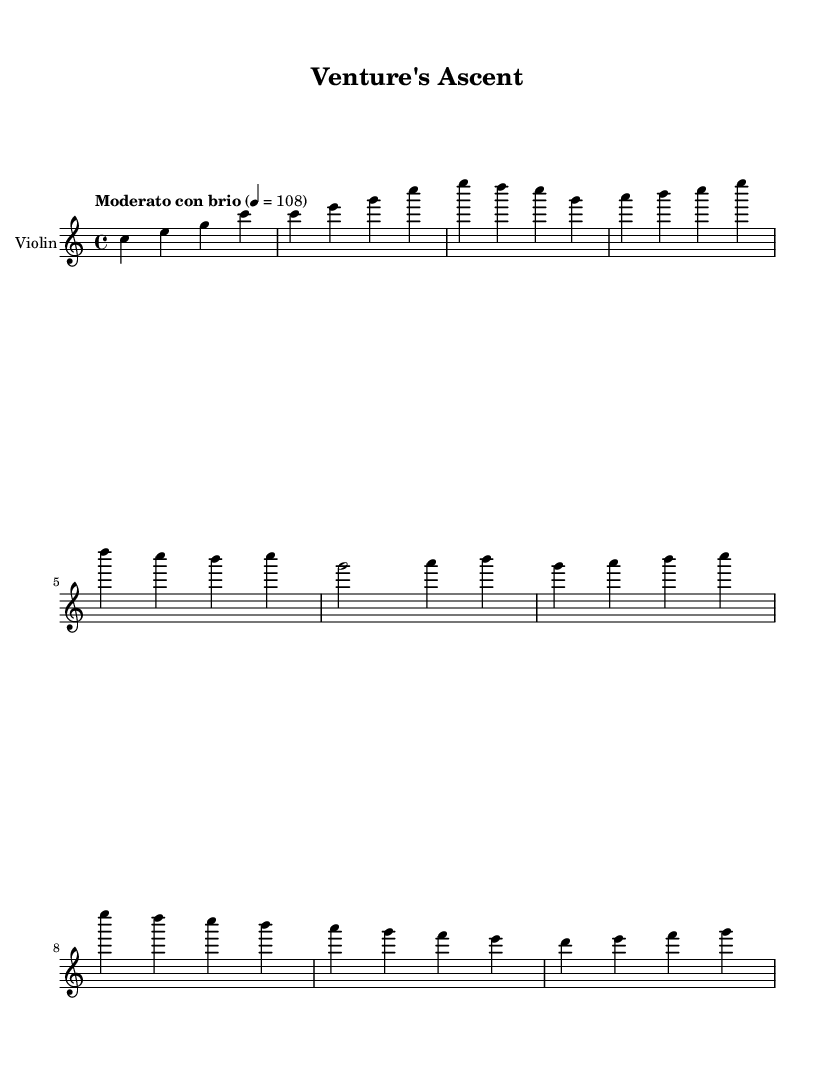What is the key signature of this music? The key signature is C major, indicated by having no sharps or flats. The key signature is found at the beginning of the staff.
Answer: C major What is the time signature of this piece? The time signature is 4/4, which specifies that there are four beats in a measure and the quarter note gets one beat. This is also found at the beginning of the score.
Answer: 4/4 What is the tempo marking of this piece? The tempo marking is "Moderato con brio," which indicates a moderately lively pace. This is stated at the beginning of the score, indicating the speed of the piece.
Answer: Moderato con brio How many measures are in the Main Theme A? Main Theme A consists of four measures, where the notes are grouped and follow the pattern given in the music. Each measure contains a specific number of beats fitting inside a 4/4 time structure.
Answer: Four measures What is the first note of the Bridge section? The first note of the Bridge section is G, as it is the first pitch introduced after the Main Theme A. The notes of the subsequent measures confirm this.
Answer: G How many different notes are played in Main Theme B? Main Theme B contains seven distinct notes: G, A, B, C, E, D, and F, which can be counted as you examine the notes across the measures.
Answer: Seven notes Which section follows the Introduction? The section that follows the Introduction is the Main Theme A, as it immediately continues on from the introductory measures. The structure of the score indicates the flow of the music.
Answer: Main Theme A 